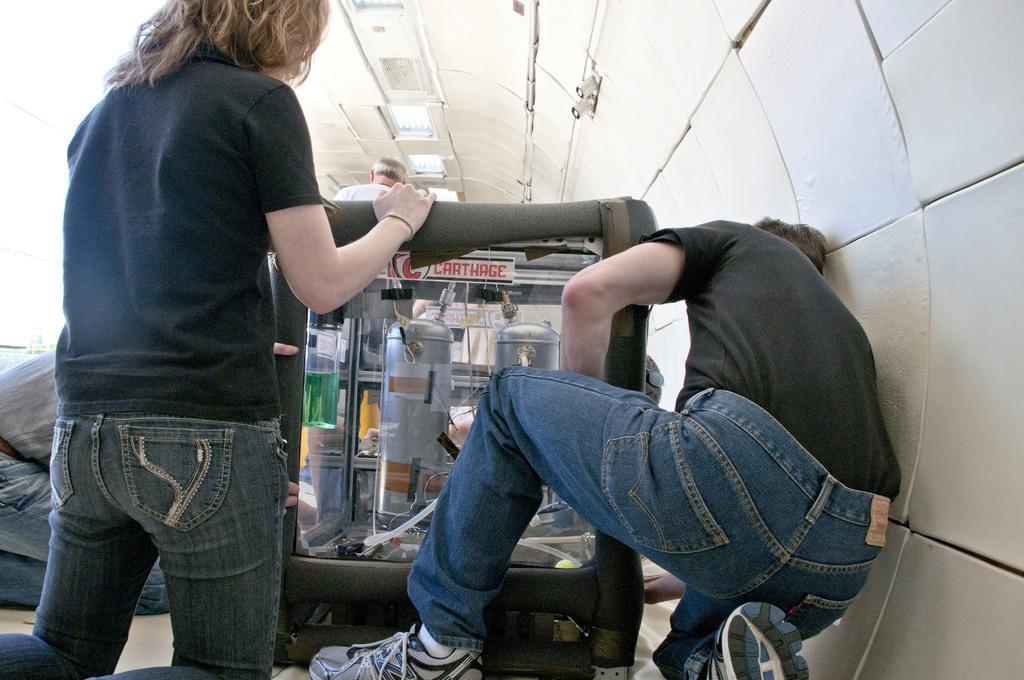Could you give a brief overview of what you see in this image? In this image I can see three people with different color dresses. In-front of these people I can see the object. In the back I can see some silver color cylinders. In the back I can see one more person and the lights. 